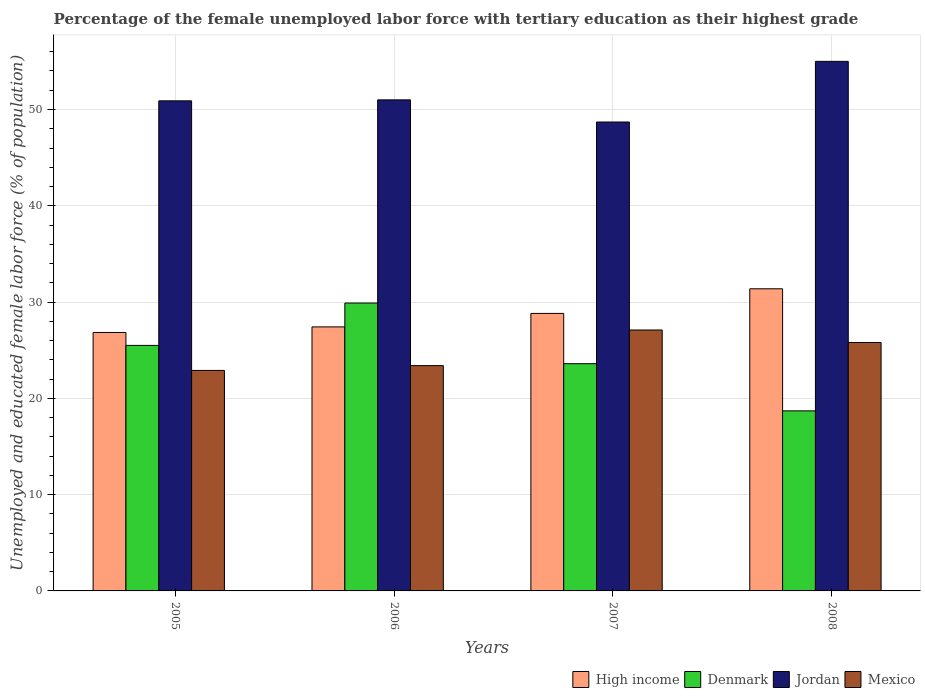Are the number of bars per tick equal to the number of legend labels?
Provide a succinct answer. Yes. Are the number of bars on each tick of the X-axis equal?
Provide a succinct answer. Yes. How many bars are there on the 4th tick from the right?
Provide a succinct answer. 4. In how many cases, is the number of bars for a given year not equal to the number of legend labels?
Your answer should be very brief. 0. What is the percentage of the unemployed female labor force with tertiary education in Denmark in 2006?
Offer a terse response. 29.9. Across all years, what is the minimum percentage of the unemployed female labor force with tertiary education in High income?
Your response must be concise. 26.84. In which year was the percentage of the unemployed female labor force with tertiary education in Jordan maximum?
Offer a terse response. 2008. What is the total percentage of the unemployed female labor force with tertiary education in High income in the graph?
Ensure brevity in your answer.  114.46. What is the difference between the percentage of the unemployed female labor force with tertiary education in Mexico in 2005 and that in 2006?
Your answer should be compact. -0.5. What is the difference between the percentage of the unemployed female labor force with tertiary education in Denmark in 2007 and the percentage of the unemployed female labor force with tertiary education in Jordan in 2006?
Provide a succinct answer. -27.4. What is the average percentage of the unemployed female labor force with tertiary education in Jordan per year?
Give a very brief answer. 51.4. In the year 2008, what is the difference between the percentage of the unemployed female labor force with tertiary education in High income and percentage of the unemployed female labor force with tertiary education in Denmark?
Provide a short and direct response. 12.68. In how many years, is the percentage of the unemployed female labor force with tertiary education in Mexico greater than 40 %?
Offer a very short reply. 0. What is the ratio of the percentage of the unemployed female labor force with tertiary education in High income in 2005 to that in 2007?
Your response must be concise. 0.93. Is the percentage of the unemployed female labor force with tertiary education in High income in 2005 less than that in 2007?
Your answer should be very brief. Yes. Is the difference between the percentage of the unemployed female labor force with tertiary education in High income in 2006 and 2007 greater than the difference between the percentage of the unemployed female labor force with tertiary education in Denmark in 2006 and 2007?
Provide a short and direct response. No. What is the difference between the highest and the second highest percentage of the unemployed female labor force with tertiary education in Mexico?
Ensure brevity in your answer.  1.3. What is the difference between the highest and the lowest percentage of the unemployed female labor force with tertiary education in Mexico?
Offer a very short reply. 4.2. What does the 2nd bar from the left in 2007 represents?
Ensure brevity in your answer.  Denmark. What does the 2nd bar from the right in 2007 represents?
Keep it short and to the point. Jordan. How many bars are there?
Give a very brief answer. 16. Are all the bars in the graph horizontal?
Your response must be concise. No. Does the graph contain any zero values?
Your answer should be very brief. No. Does the graph contain grids?
Offer a terse response. Yes. Where does the legend appear in the graph?
Give a very brief answer. Bottom right. How many legend labels are there?
Offer a very short reply. 4. What is the title of the graph?
Keep it short and to the point. Percentage of the female unemployed labor force with tertiary education as their highest grade. What is the label or title of the Y-axis?
Offer a terse response. Unemployed and educated female labor force (% of population). What is the Unemployed and educated female labor force (% of population) in High income in 2005?
Give a very brief answer. 26.84. What is the Unemployed and educated female labor force (% of population) of Jordan in 2005?
Keep it short and to the point. 50.9. What is the Unemployed and educated female labor force (% of population) of Mexico in 2005?
Your answer should be compact. 22.9. What is the Unemployed and educated female labor force (% of population) in High income in 2006?
Make the answer very short. 27.42. What is the Unemployed and educated female labor force (% of population) in Denmark in 2006?
Offer a terse response. 29.9. What is the Unemployed and educated female labor force (% of population) of Mexico in 2006?
Keep it short and to the point. 23.4. What is the Unemployed and educated female labor force (% of population) of High income in 2007?
Ensure brevity in your answer.  28.82. What is the Unemployed and educated female labor force (% of population) in Denmark in 2007?
Offer a terse response. 23.6. What is the Unemployed and educated female labor force (% of population) in Jordan in 2007?
Provide a succinct answer. 48.7. What is the Unemployed and educated female labor force (% of population) of Mexico in 2007?
Make the answer very short. 27.1. What is the Unemployed and educated female labor force (% of population) in High income in 2008?
Keep it short and to the point. 31.38. What is the Unemployed and educated female labor force (% of population) of Denmark in 2008?
Provide a short and direct response. 18.7. What is the Unemployed and educated female labor force (% of population) of Mexico in 2008?
Your answer should be compact. 25.8. Across all years, what is the maximum Unemployed and educated female labor force (% of population) in High income?
Provide a short and direct response. 31.38. Across all years, what is the maximum Unemployed and educated female labor force (% of population) of Denmark?
Make the answer very short. 29.9. Across all years, what is the maximum Unemployed and educated female labor force (% of population) of Jordan?
Give a very brief answer. 55. Across all years, what is the maximum Unemployed and educated female labor force (% of population) in Mexico?
Make the answer very short. 27.1. Across all years, what is the minimum Unemployed and educated female labor force (% of population) of High income?
Ensure brevity in your answer.  26.84. Across all years, what is the minimum Unemployed and educated female labor force (% of population) in Denmark?
Provide a succinct answer. 18.7. Across all years, what is the minimum Unemployed and educated female labor force (% of population) in Jordan?
Offer a very short reply. 48.7. Across all years, what is the minimum Unemployed and educated female labor force (% of population) of Mexico?
Provide a succinct answer. 22.9. What is the total Unemployed and educated female labor force (% of population) of High income in the graph?
Your response must be concise. 114.46. What is the total Unemployed and educated female labor force (% of population) of Denmark in the graph?
Your response must be concise. 97.7. What is the total Unemployed and educated female labor force (% of population) of Jordan in the graph?
Your answer should be compact. 205.6. What is the total Unemployed and educated female labor force (% of population) in Mexico in the graph?
Make the answer very short. 99.2. What is the difference between the Unemployed and educated female labor force (% of population) of High income in 2005 and that in 2006?
Give a very brief answer. -0.58. What is the difference between the Unemployed and educated female labor force (% of population) in Denmark in 2005 and that in 2006?
Your answer should be very brief. -4.4. What is the difference between the Unemployed and educated female labor force (% of population) in Jordan in 2005 and that in 2006?
Make the answer very short. -0.1. What is the difference between the Unemployed and educated female labor force (% of population) of High income in 2005 and that in 2007?
Ensure brevity in your answer.  -1.98. What is the difference between the Unemployed and educated female labor force (% of population) of Denmark in 2005 and that in 2007?
Keep it short and to the point. 1.9. What is the difference between the Unemployed and educated female labor force (% of population) of Mexico in 2005 and that in 2007?
Offer a terse response. -4.2. What is the difference between the Unemployed and educated female labor force (% of population) in High income in 2005 and that in 2008?
Your response must be concise. -4.54. What is the difference between the Unemployed and educated female labor force (% of population) of Jordan in 2005 and that in 2008?
Make the answer very short. -4.1. What is the difference between the Unemployed and educated female labor force (% of population) in High income in 2006 and that in 2007?
Offer a terse response. -1.4. What is the difference between the Unemployed and educated female labor force (% of population) in Mexico in 2006 and that in 2007?
Your answer should be compact. -3.7. What is the difference between the Unemployed and educated female labor force (% of population) in High income in 2006 and that in 2008?
Your answer should be compact. -3.96. What is the difference between the Unemployed and educated female labor force (% of population) of Denmark in 2006 and that in 2008?
Offer a terse response. 11.2. What is the difference between the Unemployed and educated female labor force (% of population) in Jordan in 2006 and that in 2008?
Your answer should be very brief. -4. What is the difference between the Unemployed and educated female labor force (% of population) of High income in 2007 and that in 2008?
Ensure brevity in your answer.  -2.56. What is the difference between the Unemployed and educated female labor force (% of population) of High income in 2005 and the Unemployed and educated female labor force (% of population) of Denmark in 2006?
Provide a short and direct response. -3.06. What is the difference between the Unemployed and educated female labor force (% of population) of High income in 2005 and the Unemployed and educated female labor force (% of population) of Jordan in 2006?
Your answer should be compact. -24.16. What is the difference between the Unemployed and educated female labor force (% of population) of High income in 2005 and the Unemployed and educated female labor force (% of population) of Mexico in 2006?
Make the answer very short. 3.44. What is the difference between the Unemployed and educated female labor force (% of population) of Denmark in 2005 and the Unemployed and educated female labor force (% of population) of Jordan in 2006?
Your response must be concise. -25.5. What is the difference between the Unemployed and educated female labor force (% of population) of Jordan in 2005 and the Unemployed and educated female labor force (% of population) of Mexico in 2006?
Provide a succinct answer. 27.5. What is the difference between the Unemployed and educated female labor force (% of population) in High income in 2005 and the Unemployed and educated female labor force (% of population) in Denmark in 2007?
Make the answer very short. 3.24. What is the difference between the Unemployed and educated female labor force (% of population) of High income in 2005 and the Unemployed and educated female labor force (% of population) of Jordan in 2007?
Ensure brevity in your answer.  -21.86. What is the difference between the Unemployed and educated female labor force (% of population) of High income in 2005 and the Unemployed and educated female labor force (% of population) of Mexico in 2007?
Ensure brevity in your answer.  -0.26. What is the difference between the Unemployed and educated female labor force (% of population) in Denmark in 2005 and the Unemployed and educated female labor force (% of population) in Jordan in 2007?
Ensure brevity in your answer.  -23.2. What is the difference between the Unemployed and educated female labor force (% of population) of Jordan in 2005 and the Unemployed and educated female labor force (% of population) of Mexico in 2007?
Offer a very short reply. 23.8. What is the difference between the Unemployed and educated female labor force (% of population) in High income in 2005 and the Unemployed and educated female labor force (% of population) in Denmark in 2008?
Your response must be concise. 8.14. What is the difference between the Unemployed and educated female labor force (% of population) in High income in 2005 and the Unemployed and educated female labor force (% of population) in Jordan in 2008?
Provide a succinct answer. -28.16. What is the difference between the Unemployed and educated female labor force (% of population) of High income in 2005 and the Unemployed and educated female labor force (% of population) of Mexico in 2008?
Provide a succinct answer. 1.04. What is the difference between the Unemployed and educated female labor force (% of population) in Denmark in 2005 and the Unemployed and educated female labor force (% of population) in Jordan in 2008?
Ensure brevity in your answer.  -29.5. What is the difference between the Unemployed and educated female labor force (% of population) in Jordan in 2005 and the Unemployed and educated female labor force (% of population) in Mexico in 2008?
Offer a terse response. 25.1. What is the difference between the Unemployed and educated female labor force (% of population) of High income in 2006 and the Unemployed and educated female labor force (% of population) of Denmark in 2007?
Provide a short and direct response. 3.82. What is the difference between the Unemployed and educated female labor force (% of population) of High income in 2006 and the Unemployed and educated female labor force (% of population) of Jordan in 2007?
Offer a very short reply. -21.28. What is the difference between the Unemployed and educated female labor force (% of population) in High income in 2006 and the Unemployed and educated female labor force (% of population) in Mexico in 2007?
Keep it short and to the point. 0.32. What is the difference between the Unemployed and educated female labor force (% of population) of Denmark in 2006 and the Unemployed and educated female labor force (% of population) of Jordan in 2007?
Your answer should be compact. -18.8. What is the difference between the Unemployed and educated female labor force (% of population) in Denmark in 2006 and the Unemployed and educated female labor force (% of population) in Mexico in 2007?
Ensure brevity in your answer.  2.8. What is the difference between the Unemployed and educated female labor force (% of population) in Jordan in 2006 and the Unemployed and educated female labor force (% of population) in Mexico in 2007?
Give a very brief answer. 23.9. What is the difference between the Unemployed and educated female labor force (% of population) of High income in 2006 and the Unemployed and educated female labor force (% of population) of Denmark in 2008?
Provide a succinct answer. 8.72. What is the difference between the Unemployed and educated female labor force (% of population) in High income in 2006 and the Unemployed and educated female labor force (% of population) in Jordan in 2008?
Offer a very short reply. -27.58. What is the difference between the Unemployed and educated female labor force (% of population) in High income in 2006 and the Unemployed and educated female labor force (% of population) in Mexico in 2008?
Provide a succinct answer. 1.62. What is the difference between the Unemployed and educated female labor force (% of population) in Denmark in 2006 and the Unemployed and educated female labor force (% of population) in Jordan in 2008?
Your response must be concise. -25.1. What is the difference between the Unemployed and educated female labor force (% of population) in Jordan in 2006 and the Unemployed and educated female labor force (% of population) in Mexico in 2008?
Offer a very short reply. 25.2. What is the difference between the Unemployed and educated female labor force (% of population) of High income in 2007 and the Unemployed and educated female labor force (% of population) of Denmark in 2008?
Your answer should be compact. 10.12. What is the difference between the Unemployed and educated female labor force (% of population) in High income in 2007 and the Unemployed and educated female labor force (% of population) in Jordan in 2008?
Offer a terse response. -26.18. What is the difference between the Unemployed and educated female labor force (% of population) of High income in 2007 and the Unemployed and educated female labor force (% of population) of Mexico in 2008?
Give a very brief answer. 3.02. What is the difference between the Unemployed and educated female labor force (% of population) of Denmark in 2007 and the Unemployed and educated female labor force (% of population) of Jordan in 2008?
Keep it short and to the point. -31.4. What is the difference between the Unemployed and educated female labor force (% of population) in Jordan in 2007 and the Unemployed and educated female labor force (% of population) in Mexico in 2008?
Offer a terse response. 22.9. What is the average Unemployed and educated female labor force (% of population) in High income per year?
Provide a succinct answer. 28.62. What is the average Unemployed and educated female labor force (% of population) of Denmark per year?
Your response must be concise. 24.43. What is the average Unemployed and educated female labor force (% of population) of Jordan per year?
Your answer should be very brief. 51.4. What is the average Unemployed and educated female labor force (% of population) of Mexico per year?
Your answer should be compact. 24.8. In the year 2005, what is the difference between the Unemployed and educated female labor force (% of population) in High income and Unemployed and educated female labor force (% of population) in Denmark?
Provide a short and direct response. 1.34. In the year 2005, what is the difference between the Unemployed and educated female labor force (% of population) of High income and Unemployed and educated female labor force (% of population) of Jordan?
Offer a terse response. -24.06. In the year 2005, what is the difference between the Unemployed and educated female labor force (% of population) of High income and Unemployed and educated female labor force (% of population) of Mexico?
Your response must be concise. 3.94. In the year 2005, what is the difference between the Unemployed and educated female labor force (% of population) of Denmark and Unemployed and educated female labor force (% of population) of Jordan?
Provide a succinct answer. -25.4. In the year 2005, what is the difference between the Unemployed and educated female labor force (% of population) of Denmark and Unemployed and educated female labor force (% of population) of Mexico?
Offer a very short reply. 2.6. In the year 2005, what is the difference between the Unemployed and educated female labor force (% of population) of Jordan and Unemployed and educated female labor force (% of population) of Mexico?
Give a very brief answer. 28. In the year 2006, what is the difference between the Unemployed and educated female labor force (% of population) in High income and Unemployed and educated female labor force (% of population) in Denmark?
Your answer should be compact. -2.48. In the year 2006, what is the difference between the Unemployed and educated female labor force (% of population) of High income and Unemployed and educated female labor force (% of population) of Jordan?
Give a very brief answer. -23.58. In the year 2006, what is the difference between the Unemployed and educated female labor force (% of population) in High income and Unemployed and educated female labor force (% of population) in Mexico?
Provide a short and direct response. 4.02. In the year 2006, what is the difference between the Unemployed and educated female labor force (% of population) of Denmark and Unemployed and educated female labor force (% of population) of Jordan?
Provide a short and direct response. -21.1. In the year 2006, what is the difference between the Unemployed and educated female labor force (% of population) of Denmark and Unemployed and educated female labor force (% of population) of Mexico?
Keep it short and to the point. 6.5. In the year 2006, what is the difference between the Unemployed and educated female labor force (% of population) in Jordan and Unemployed and educated female labor force (% of population) in Mexico?
Provide a succinct answer. 27.6. In the year 2007, what is the difference between the Unemployed and educated female labor force (% of population) in High income and Unemployed and educated female labor force (% of population) in Denmark?
Ensure brevity in your answer.  5.22. In the year 2007, what is the difference between the Unemployed and educated female labor force (% of population) of High income and Unemployed and educated female labor force (% of population) of Jordan?
Provide a succinct answer. -19.88. In the year 2007, what is the difference between the Unemployed and educated female labor force (% of population) in High income and Unemployed and educated female labor force (% of population) in Mexico?
Your answer should be very brief. 1.72. In the year 2007, what is the difference between the Unemployed and educated female labor force (% of population) in Denmark and Unemployed and educated female labor force (% of population) in Jordan?
Offer a terse response. -25.1. In the year 2007, what is the difference between the Unemployed and educated female labor force (% of population) of Jordan and Unemployed and educated female labor force (% of population) of Mexico?
Provide a short and direct response. 21.6. In the year 2008, what is the difference between the Unemployed and educated female labor force (% of population) in High income and Unemployed and educated female labor force (% of population) in Denmark?
Provide a succinct answer. 12.68. In the year 2008, what is the difference between the Unemployed and educated female labor force (% of population) in High income and Unemployed and educated female labor force (% of population) in Jordan?
Keep it short and to the point. -23.62. In the year 2008, what is the difference between the Unemployed and educated female labor force (% of population) of High income and Unemployed and educated female labor force (% of population) of Mexico?
Your answer should be compact. 5.58. In the year 2008, what is the difference between the Unemployed and educated female labor force (% of population) of Denmark and Unemployed and educated female labor force (% of population) of Jordan?
Make the answer very short. -36.3. In the year 2008, what is the difference between the Unemployed and educated female labor force (% of population) in Jordan and Unemployed and educated female labor force (% of population) in Mexico?
Provide a succinct answer. 29.2. What is the ratio of the Unemployed and educated female labor force (% of population) of High income in 2005 to that in 2006?
Provide a short and direct response. 0.98. What is the ratio of the Unemployed and educated female labor force (% of population) of Denmark in 2005 to that in 2006?
Keep it short and to the point. 0.85. What is the ratio of the Unemployed and educated female labor force (% of population) of Jordan in 2005 to that in 2006?
Your answer should be very brief. 1. What is the ratio of the Unemployed and educated female labor force (% of population) in Mexico in 2005 to that in 2006?
Your answer should be very brief. 0.98. What is the ratio of the Unemployed and educated female labor force (% of population) in High income in 2005 to that in 2007?
Keep it short and to the point. 0.93. What is the ratio of the Unemployed and educated female labor force (% of population) of Denmark in 2005 to that in 2007?
Offer a very short reply. 1.08. What is the ratio of the Unemployed and educated female labor force (% of population) of Jordan in 2005 to that in 2007?
Provide a short and direct response. 1.05. What is the ratio of the Unemployed and educated female labor force (% of population) in Mexico in 2005 to that in 2007?
Keep it short and to the point. 0.84. What is the ratio of the Unemployed and educated female labor force (% of population) of High income in 2005 to that in 2008?
Provide a short and direct response. 0.86. What is the ratio of the Unemployed and educated female labor force (% of population) in Denmark in 2005 to that in 2008?
Give a very brief answer. 1.36. What is the ratio of the Unemployed and educated female labor force (% of population) in Jordan in 2005 to that in 2008?
Your response must be concise. 0.93. What is the ratio of the Unemployed and educated female labor force (% of population) in Mexico in 2005 to that in 2008?
Make the answer very short. 0.89. What is the ratio of the Unemployed and educated female labor force (% of population) in High income in 2006 to that in 2007?
Your response must be concise. 0.95. What is the ratio of the Unemployed and educated female labor force (% of population) in Denmark in 2006 to that in 2007?
Your answer should be very brief. 1.27. What is the ratio of the Unemployed and educated female labor force (% of population) in Jordan in 2006 to that in 2007?
Ensure brevity in your answer.  1.05. What is the ratio of the Unemployed and educated female labor force (% of population) of Mexico in 2006 to that in 2007?
Your response must be concise. 0.86. What is the ratio of the Unemployed and educated female labor force (% of population) in High income in 2006 to that in 2008?
Offer a terse response. 0.87. What is the ratio of the Unemployed and educated female labor force (% of population) in Denmark in 2006 to that in 2008?
Make the answer very short. 1.6. What is the ratio of the Unemployed and educated female labor force (% of population) in Jordan in 2006 to that in 2008?
Ensure brevity in your answer.  0.93. What is the ratio of the Unemployed and educated female labor force (% of population) of Mexico in 2006 to that in 2008?
Provide a succinct answer. 0.91. What is the ratio of the Unemployed and educated female labor force (% of population) of High income in 2007 to that in 2008?
Offer a terse response. 0.92. What is the ratio of the Unemployed and educated female labor force (% of population) of Denmark in 2007 to that in 2008?
Keep it short and to the point. 1.26. What is the ratio of the Unemployed and educated female labor force (% of population) of Jordan in 2007 to that in 2008?
Your response must be concise. 0.89. What is the ratio of the Unemployed and educated female labor force (% of population) of Mexico in 2007 to that in 2008?
Offer a very short reply. 1.05. What is the difference between the highest and the second highest Unemployed and educated female labor force (% of population) in High income?
Give a very brief answer. 2.56. What is the difference between the highest and the second highest Unemployed and educated female labor force (% of population) in Denmark?
Provide a succinct answer. 4.4. What is the difference between the highest and the second highest Unemployed and educated female labor force (% of population) of Mexico?
Offer a terse response. 1.3. What is the difference between the highest and the lowest Unemployed and educated female labor force (% of population) of High income?
Your answer should be very brief. 4.54. What is the difference between the highest and the lowest Unemployed and educated female labor force (% of population) of Denmark?
Provide a short and direct response. 11.2. What is the difference between the highest and the lowest Unemployed and educated female labor force (% of population) in Jordan?
Provide a succinct answer. 6.3. What is the difference between the highest and the lowest Unemployed and educated female labor force (% of population) in Mexico?
Give a very brief answer. 4.2. 